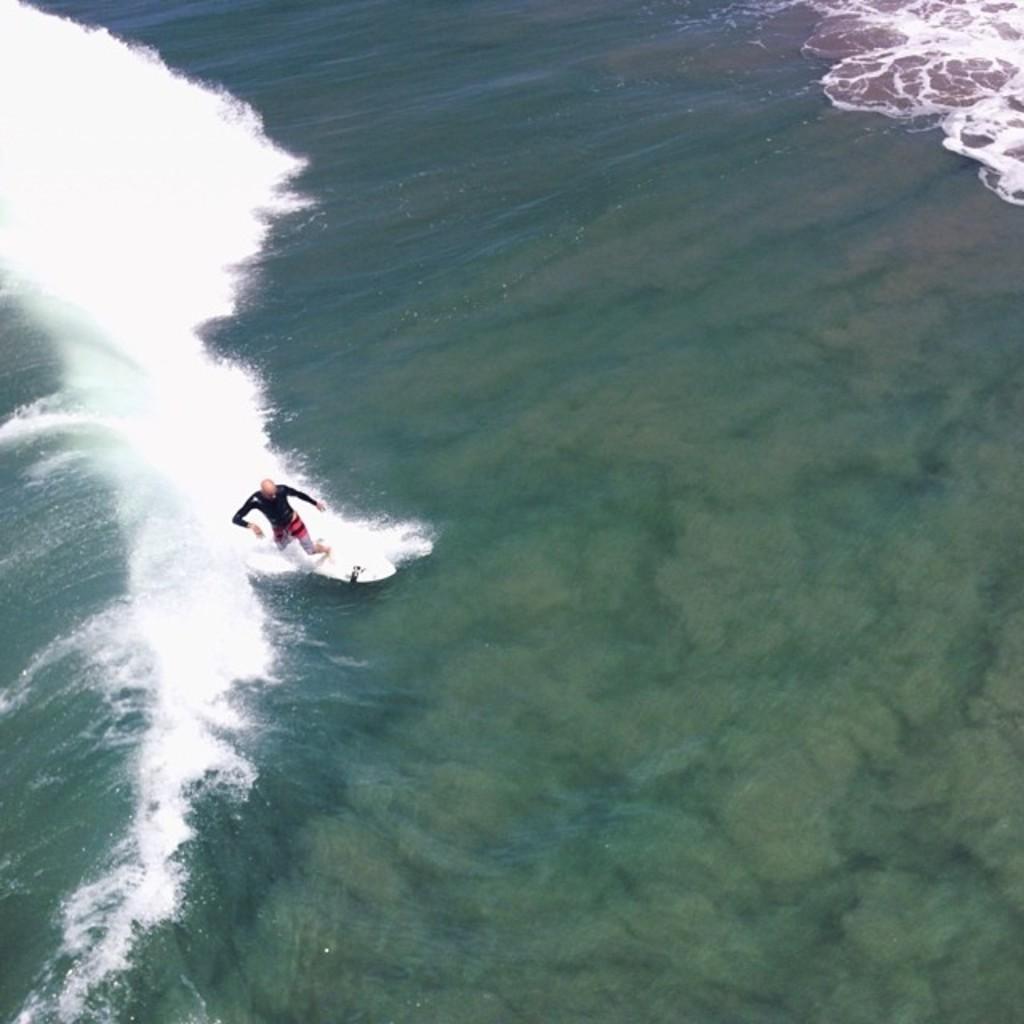Please provide a concise description of this image. In this image we can see the sea, one man standing on the surfboard and surfing in the sea. 